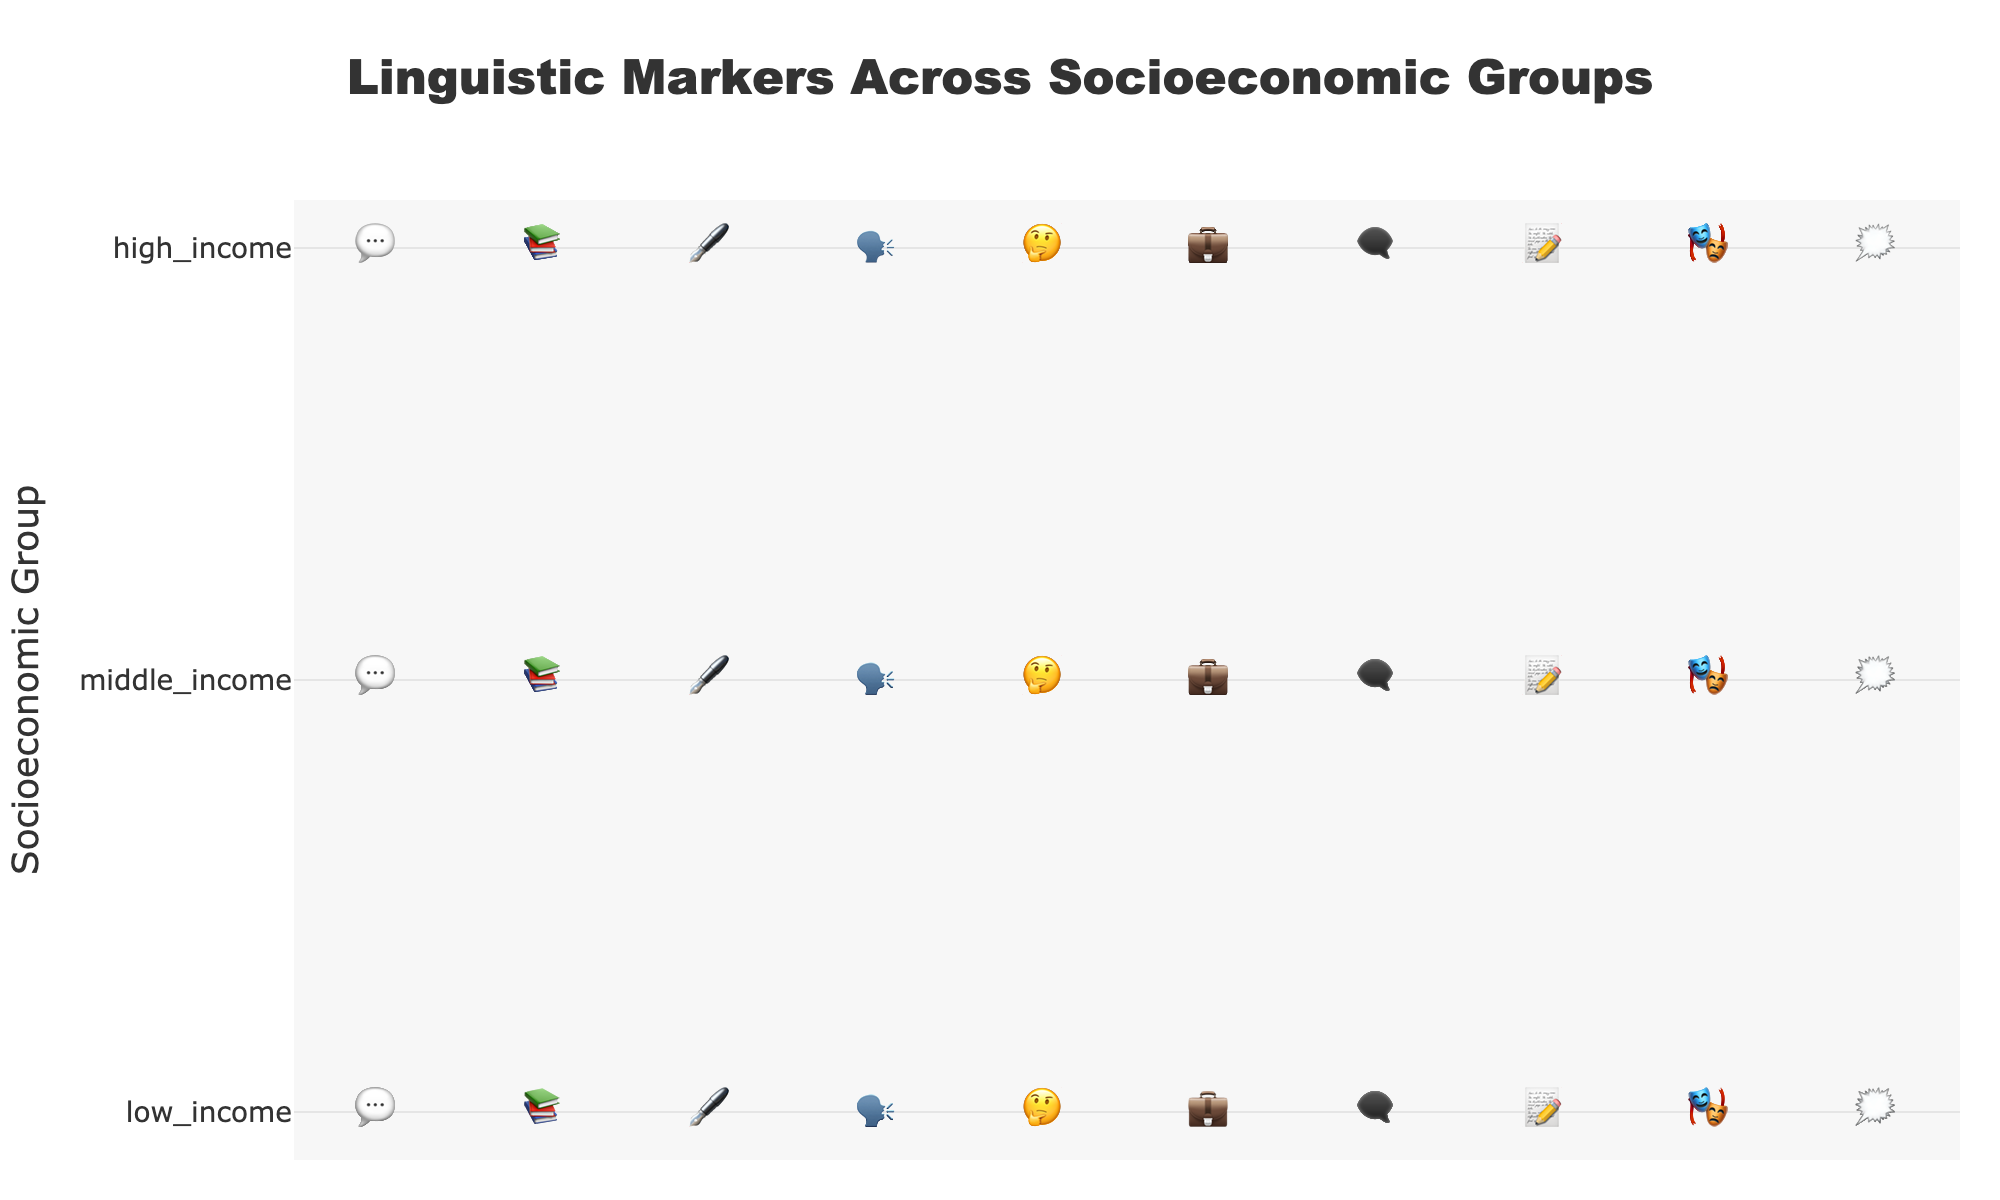what is the title of the figure? The title of the figure is centered at the top, displaying information about the figure's content.
Answer: Linguistic Markers Across Socioeconomic Groups which socioeconomic group uses slang the most? Look for the marker representing slang (💬) and count the occurrences in each socioeconomic group. The highest count is in the low-income group.
Answer: low_income how many total instances of professional jargon are there? Sum up the number of professional jargon markers (💼) across all socioeconomic groups (low:1, mid:4, high:8). 1+4+8=13
Answer: 13 which linguistic marker is most commonly used in the middle-income group? Identify each type of marker in the middle-income row and count the number of each. Colloquialisms (🗨️) and hedging language (🤔) have the highest counts with 6 instances each.
Answer: colloquialisms and hedging_language how many more times is formal grammar used in the high-income group than in the low-income group? Compare the counts of formal grammar (🖋️) markers between high-income (9) and low-income (3). Subtract to find the difference: 9-3=6.
Answer: 6 which group uses filler words the least, and how many do they use? Locate the marker for filler words (🗯️) and count the occurrences per group. High-income group has the lowest count with 2 instances.
Answer: high_income, 2 compare the usage of regional dialect across all groups. which group uses it the least? Find the counts of regional dialect markers (🗣️) for each group (low:7, mid:4, high:1). High-income has the least with 1 instance.
Answer: high_income which linguistic marker has the greatest disparity between high-income and low-income groups? Calculate the difference in usage for each marker between high-income and low-income groups and find the maximum difference. Formal grammar (🖋️) has the greatest disparity: 9 (high) - 3 (low) = 6.
Answer: formal_grammar how does the usage of complex vocabulary vary across socioeconomic groups? Identify the complex vocabulary marker (📚) counts for each group (low:2, mid:5, high:8). Describe the trend: it increases from low to high-income groups.
Answer: increases from low to high-income groups 